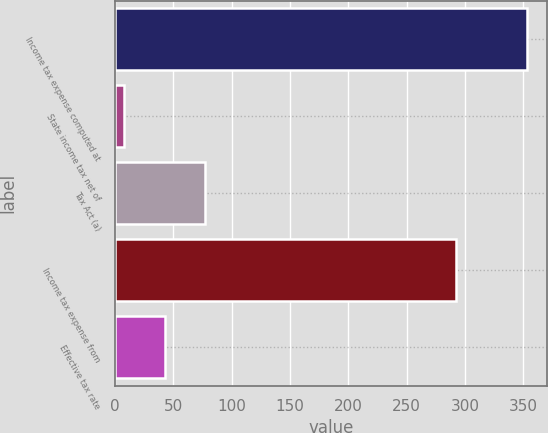Convert chart to OTSL. <chart><loc_0><loc_0><loc_500><loc_500><bar_chart><fcel>Income tax expense computed at<fcel>State income tax net of<fcel>Tax Act (a)<fcel>Income tax expense from<fcel>Effective tax rate<nl><fcel>353<fcel>8<fcel>77<fcel>292<fcel>42.5<nl></chart> 